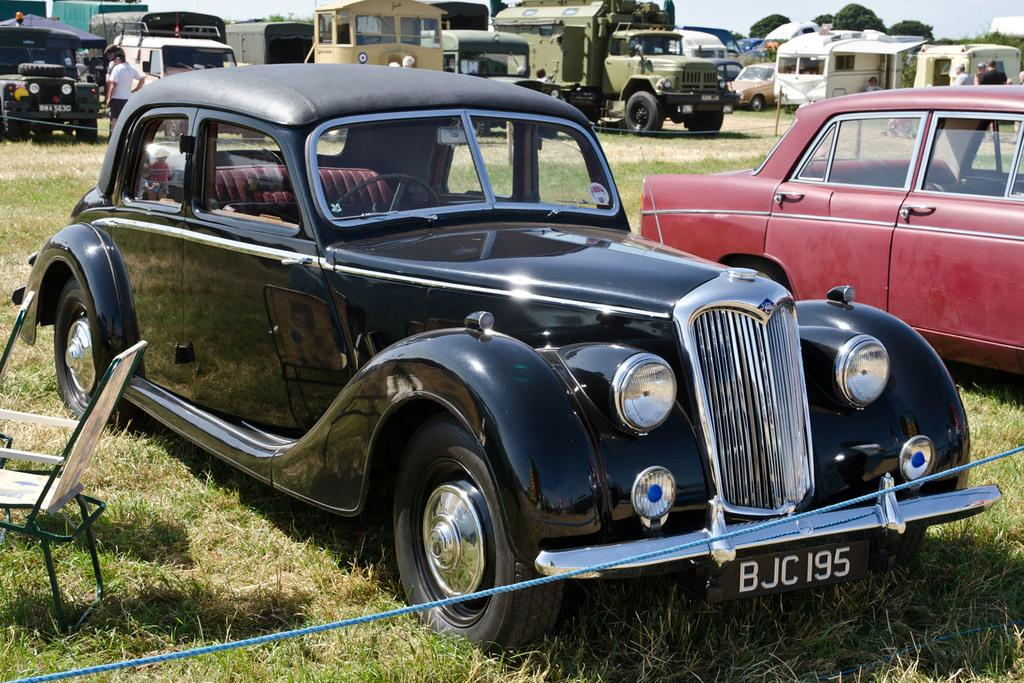What types of objects are on the ground in the image? There are vehicles and other objects on the ground in the image. Can you describe the people in the image? There are people visible in the image. What type of vegetation can be seen in the image? There is grass and trees visible in the image. What else is present in the image besides the people and objects on the ground? Wires and a chair are present in the image. What is visible in the background of the image? The sky is visible in the background of the image. What type of cord is being used by the organization in the image? There is no mention of an organization or a cord in the image. Can you see any boots in the image? There are no boots visible in the image. 